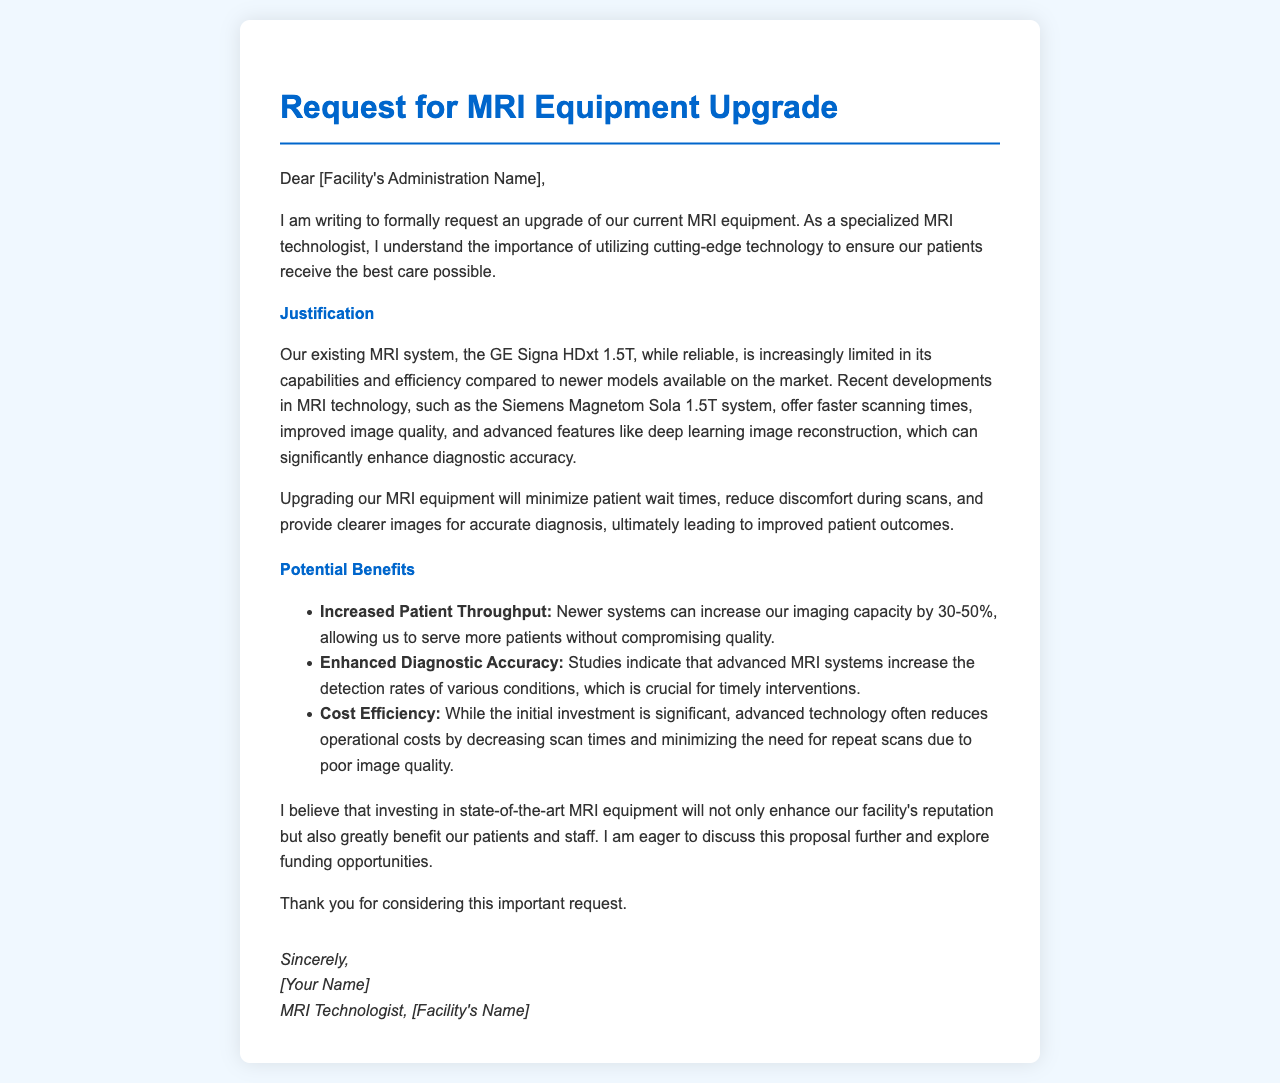What is the current MRI system mentioned? The document states the current MRI system is the GE Signa HDxt 1.5T.
Answer: GE Signa HDxt 1.5T What is the proposed MRI system for the upgrade? The letter proposes upgrading to the Siemens Magnetom Sola 1.5T system.
Answer: Siemens Magnetom Sola 1.5T What is the potential increase in imaging capacity? The document mentions that newer systems can increase imaging capacity by 30-50%.
Answer: 30-50% What is one of the benefits related to scan times? It is noted that advanced technology often reduces operational costs by decreasing scan times.
Answer: Decreasing scan times Who is the letter addressed to? The letter is addressed to the facility's administration, which is indicated at the beginning.
Answer: Facility's Administration What is the concluding request in the letter? The letter concludes with a request to discuss the proposal further and explore funding opportunities.
Answer: Discuss the proposal further 